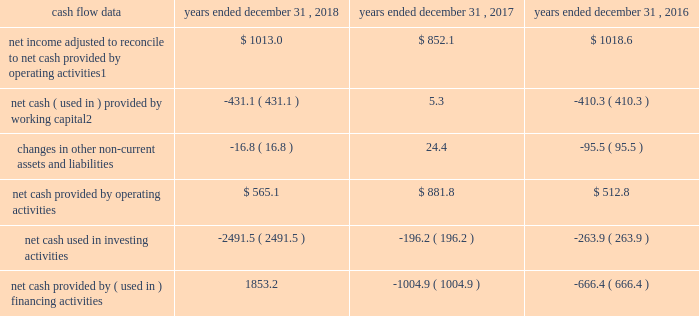Management 2019s discussion and analysis of financial condition and results of operations 2013 ( continued ) ( amounts in millions , except per share amounts ) liquidity and capital resources cash flow overview the tables summarize key financial data relating to our liquidity , capital resources and uses of capital. .
1 reflects net income adjusted primarily for depreciation and amortization of fixed assets and intangible assets , amortization of restricted stock and other non-cash compensation , net losses on sales of businesses and deferred income taxes .
2 reflects changes in accounts receivable , accounts receivable billable to clients , other current assets , accounts payable and accrued liabilities .
Operating activities due to the seasonality of our business , we typically use cash from working capital in the first nine months of a year , with the largest impact in the first quarter , and generate cash from working capital in the fourth quarter , driven by the seasonally strong media spending by our clients .
Quarterly and annual working capital results are impacted by the fluctuating annual media spending budgets of our clients as well as their changing media spending patterns throughout each year across various countries .
The timing of media buying on behalf of our clients across various countries affects our working capital and operating cash flow and can be volatile .
In most of our businesses , our agencies enter into commitments to pay production and media costs on behalf of clients .
To the extent possible , we pay production and media charges after we have received funds from our clients .
The amounts involved , which substantially exceed our revenues , primarily affect the level of accounts receivable , accounts payable , accrued liabilities and contract liabilities .
Our assets include both cash received and accounts receivable from clients for these pass-through arrangements , while our liabilities include amounts owed on behalf of clients to media and production suppliers .
Our accrued liabilities are also affected by the timing of certain other payments .
For example , while annual cash incentive awards are accrued throughout the year , they are generally paid during the first quarter of the subsequent year .
Net cash provided by operating activities during 2018 was $ 565.1 , which was a decrease of $ 316.7 as compared to 2017 , primarily as a result of an increase in working capital usage of $ 436.4 .
Working capital in 2018 was impacted by the spending levels of our clients as compared to 2017 .
The working capital usage in both periods was primarily attributable to our media businesses .
Net cash provided by operating activities during 2017 was $ 881.8 , which was an increase of $ 369.0 as compared to 2016 , primarily as a result of an improvement in working capital usage of $ 415.6 .
Working capital in 2017 benefited from the spending patterns of our clients compared to 2016 .
Investing activities net cash used in investing activities during 2018 consisted of payments for acquisitions of $ 2309.8 , related mostly to the acxiom acquisition , and payments for capital expenditures of $ 177.1 , related mostly to leasehold improvements and computer hardware and software. .
What is the mathematical range for net cash provided by ( used in ) financing activities? 
Computations: (1853.2 - -1004.9)
Answer: 2858.1. 